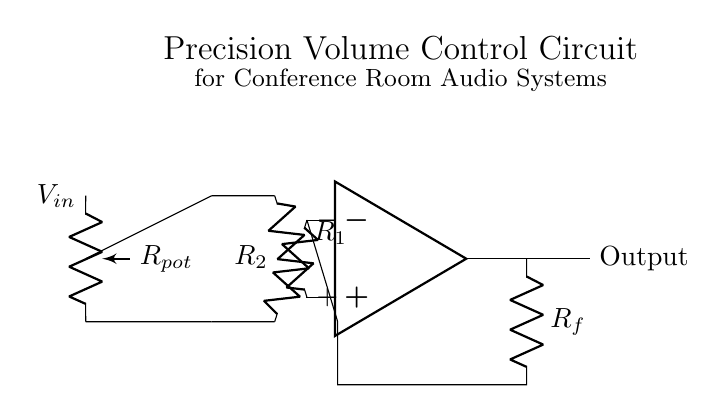What type of components are used in this circuit? The circuit consists of resistors, an operational amplifier, and a potentiometer; specifically, there are two fixed resistors (R1, R2), one feedback resistor (Rf), and one variable resistor (Rpot).
Answer: resistors, operational amplifier, potentiometer What is the role of Rpot in this circuit? The potentiometer (Rpot) acts as a variable resistor, allowing for precise adjustment of the input voltage, thus controlling the volume output of the audio system.
Answer: volume control How many resistors are present in the circuit? There are three resistors in total: R1, R2, and Rf. Rpot is a fourth resistor type, but it is variable.
Answer: three What is the function of the operational amplifier in this circuit? The operational amplifier is used for signal amplification, taking the input from R1 and R2, and controlling the output based on feedback via Rf, enabling precise volume adjustments.
Answer: signal amplification What are the input terminals of the operational amplifier labeled as? The input terminals are labeled with a positive sign (+) and a negative sign (-), indicating non-inverting and inverting inputs respectively.
Answer: positive and negative What would happen if Rf is increased in value? Increasing the value of Rf will increase the overall gain of the amplifier, amplifying the output signal more significantly, which can lead to a louder volume output if all other components remain constant.
Answer: increased gain How does R2 influence the circuit's behavior? R2, being connected to the inverting terminal, helps determine the gain of the operational amplifier along with Rf; a change in R2 will inversely affect the gain of the circuit, thereby impacting volume control.
Answer: determines gain 